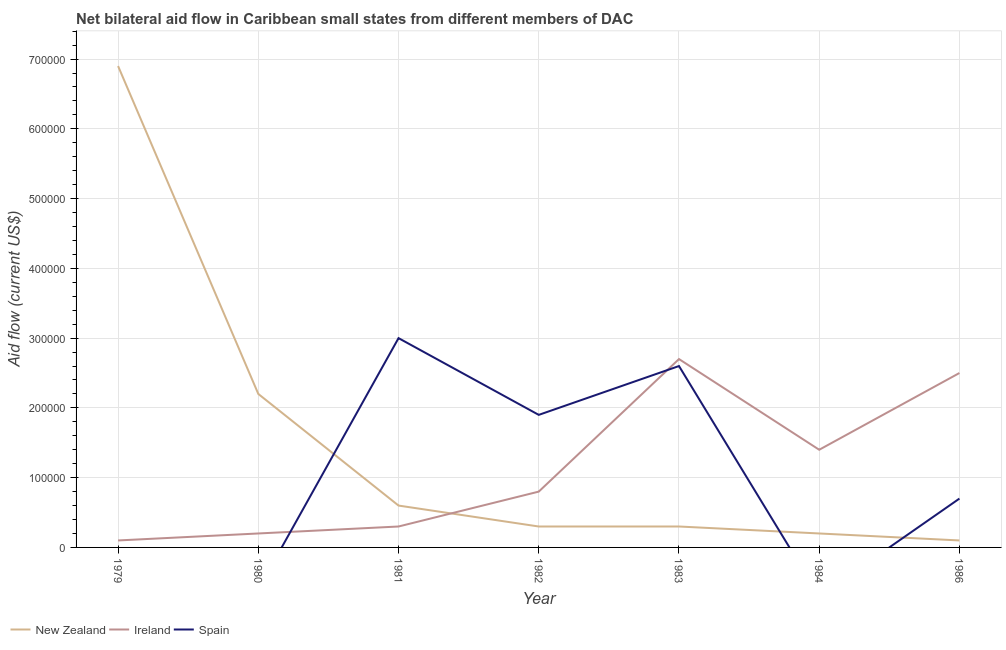Is the number of lines equal to the number of legend labels?
Offer a very short reply. No. What is the amount of aid provided by spain in 1983?
Offer a very short reply. 2.60e+05. Across all years, what is the maximum amount of aid provided by new zealand?
Provide a succinct answer. 6.90e+05. Across all years, what is the minimum amount of aid provided by ireland?
Make the answer very short. 10000. What is the total amount of aid provided by spain in the graph?
Provide a short and direct response. 8.20e+05. What is the difference between the amount of aid provided by new zealand in 1984 and that in 1986?
Provide a succinct answer. 10000. What is the difference between the amount of aid provided by new zealand in 1983 and the amount of aid provided by spain in 1981?
Ensure brevity in your answer.  -2.70e+05. What is the average amount of aid provided by spain per year?
Keep it short and to the point. 1.17e+05. In the year 1986, what is the difference between the amount of aid provided by new zealand and amount of aid provided by spain?
Keep it short and to the point. -6.00e+04. What is the ratio of the amount of aid provided by new zealand in 1979 to that in 1981?
Make the answer very short. 11.5. What is the difference between the highest and the lowest amount of aid provided by new zealand?
Your answer should be compact. 6.80e+05. In how many years, is the amount of aid provided by ireland greater than the average amount of aid provided by ireland taken over all years?
Make the answer very short. 3. Is the amount of aid provided by ireland strictly less than the amount of aid provided by new zealand over the years?
Provide a succinct answer. No. How many lines are there?
Your answer should be compact. 3. Are the values on the major ticks of Y-axis written in scientific E-notation?
Ensure brevity in your answer.  No. Does the graph contain any zero values?
Provide a short and direct response. Yes. Where does the legend appear in the graph?
Provide a succinct answer. Bottom left. How many legend labels are there?
Make the answer very short. 3. How are the legend labels stacked?
Your answer should be compact. Horizontal. What is the title of the graph?
Offer a terse response. Net bilateral aid flow in Caribbean small states from different members of DAC. What is the Aid flow (current US$) in New Zealand in 1979?
Make the answer very short. 6.90e+05. What is the Aid flow (current US$) of New Zealand in 1980?
Ensure brevity in your answer.  2.20e+05. What is the Aid flow (current US$) in Ireland in 1980?
Offer a very short reply. 2.00e+04. What is the Aid flow (current US$) in Spain in 1981?
Your response must be concise. 3.00e+05. What is the Aid flow (current US$) in Ireland in 1982?
Your response must be concise. 8.00e+04. What is the Aid flow (current US$) in Spain in 1982?
Keep it short and to the point. 1.90e+05. What is the Aid flow (current US$) of New Zealand in 1983?
Your answer should be very brief. 3.00e+04. What is the Aid flow (current US$) in Spain in 1983?
Provide a short and direct response. 2.60e+05. What is the Aid flow (current US$) in Ireland in 1984?
Ensure brevity in your answer.  1.40e+05. What is the Aid flow (current US$) of New Zealand in 1986?
Keep it short and to the point. 10000. What is the Aid flow (current US$) of Spain in 1986?
Make the answer very short. 7.00e+04. Across all years, what is the maximum Aid flow (current US$) in New Zealand?
Your answer should be very brief. 6.90e+05. Across all years, what is the minimum Aid flow (current US$) of New Zealand?
Provide a succinct answer. 10000. Across all years, what is the minimum Aid flow (current US$) in Ireland?
Give a very brief answer. 10000. What is the total Aid flow (current US$) in New Zealand in the graph?
Your answer should be very brief. 1.06e+06. What is the total Aid flow (current US$) of Ireland in the graph?
Provide a short and direct response. 8.00e+05. What is the total Aid flow (current US$) of Spain in the graph?
Your answer should be compact. 8.20e+05. What is the difference between the Aid flow (current US$) of New Zealand in 1979 and that in 1980?
Offer a very short reply. 4.70e+05. What is the difference between the Aid flow (current US$) in Ireland in 1979 and that in 1980?
Provide a succinct answer. -10000. What is the difference between the Aid flow (current US$) in New Zealand in 1979 and that in 1981?
Keep it short and to the point. 6.30e+05. What is the difference between the Aid flow (current US$) in Ireland in 1979 and that in 1981?
Offer a terse response. -2.00e+04. What is the difference between the Aid flow (current US$) of New Zealand in 1979 and that in 1984?
Keep it short and to the point. 6.70e+05. What is the difference between the Aid flow (current US$) in Ireland in 1979 and that in 1984?
Your answer should be very brief. -1.30e+05. What is the difference between the Aid flow (current US$) of New Zealand in 1979 and that in 1986?
Your answer should be very brief. 6.80e+05. What is the difference between the Aid flow (current US$) of Ireland in 1979 and that in 1986?
Ensure brevity in your answer.  -2.40e+05. What is the difference between the Aid flow (current US$) of New Zealand in 1980 and that in 1981?
Keep it short and to the point. 1.60e+05. What is the difference between the Aid flow (current US$) of New Zealand in 1980 and that in 1983?
Make the answer very short. 1.90e+05. What is the difference between the Aid flow (current US$) in Ireland in 1980 and that in 1983?
Provide a succinct answer. -2.50e+05. What is the difference between the Aid flow (current US$) in Ireland in 1980 and that in 1984?
Keep it short and to the point. -1.20e+05. What is the difference between the Aid flow (current US$) of Ireland in 1981 and that in 1982?
Keep it short and to the point. -5.00e+04. What is the difference between the Aid flow (current US$) of Spain in 1981 and that in 1982?
Your response must be concise. 1.10e+05. What is the difference between the Aid flow (current US$) of Ireland in 1981 and that in 1983?
Keep it short and to the point. -2.40e+05. What is the difference between the Aid flow (current US$) of New Zealand in 1981 and that in 1984?
Keep it short and to the point. 4.00e+04. What is the difference between the Aid flow (current US$) of Spain in 1981 and that in 1986?
Ensure brevity in your answer.  2.30e+05. What is the difference between the Aid flow (current US$) in New Zealand in 1982 and that in 1983?
Your answer should be compact. 0. What is the difference between the Aid flow (current US$) in Ireland in 1982 and that in 1983?
Offer a very short reply. -1.90e+05. What is the difference between the Aid flow (current US$) in Ireland in 1982 and that in 1984?
Keep it short and to the point. -6.00e+04. What is the difference between the Aid flow (current US$) of New Zealand in 1982 and that in 1986?
Make the answer very short. 2.00e+04. What is the difference between the Aid flow (current US$) in Ireland in 1982 and that in 1986?
Give a very brief answer. -1.70e+05. What is the difference between the Aid flow (current US$) of New Zealand in 1983 and that in 1984?
Provide a short and direct response. 10000. What is the difference between the Aid flow (current US$) of New Zealand in 1984 and that in 1986?
Your answer should be compact. 10000. What is the difference between the Aid flow (current US$) of New Zealand in 1979 and the Aid flow (current US$) of Ireland in 1980?
Provide a short and direct response. 6.70e+05. What is the difference between the Aid flow (current US$) of New Zealand in 1979 and the Aid flow (current US$) of Spain in 1981?
Provide a succinct answer. 3.90e+05. What is the difference between the Aid flow (current US$) of New Zealand in 1979 and the Aid flow (current US$) of Spain in 1982?
Offer a terse response. 5.00e+05. What is the difference between the Aid flow (current US$) in Ireland in 1979 and the Aid flow (current US$) in Spain in 1982?
Give a very brief answer. -1.80e+05. What is the difference between the Aid flow (current US$) of Ireland in 1979 and the Aid flow (current US$) of Spain in 1983?
Give a very brief answer. -2.50e+05. What is the difference between the Aid flow (current US$) in New Zealand in 1979 and the Aid flow (current US$) in Ireland in 1986?
Make the answer very short. 4.40e+05. What is the difference between the Aid flow (current US$) in New Zealand in 1979 and the Aid flow (current US$) in Spain in 1986?
Provide a short and direct response. 6.20e+05. What is the difference between the Aid flow (current US$) in New Zealand in 1980 and the Aid flow (current US$) in Ireland in 1981?
Your answer should be very brief. 1.90e+05. What is the difference between the Aid flow (current US$) of New Zealand in 1980 and the Aid flow (current US$) of Spain in 1981?
Your answer should be compact. -8.00e+04. What is the difference between the Aid flow (current US$) in Ireland in 1980 and the Aid flow (current US$) in Spain in 1981?
Provide a short and direct response. -2.80e+05. What is the difference between the Aid flow (current US$) in New Zealand in 1980 and the Aid flow (current US$) in Spain in 1983?
Provide a succinct answer. -4.00e+04. What is the difference between the Aid flow (current US$) of New Zealand in 1980 and the Aid flow (current US$) of Spain in 1986?
Provide a succinct answer. 1.50e+05. What is the difference between the Aid flow (current US$) of New Zealand in 1981 and the Aid flow (current US$) of Ireland in 1982?
Give a very brief answer. -2.00e+04. What is the difference between the Aid flow (current US$) in New Zealand in 1981 and the Aid flow (current US$) in Spain in 1982?
Make the answer very short. -1.30e+05. What is the difference between the Aid flow (current US$) of New Zealand in 1981 and the Aid flow (current US$) of Ireland in 1983?
Offer a terse response. -2.10e+05. What is the difference between the Aid flow (current US$) in New Zealand in 1981 and the Aid flow (current US$) in Ireland in 1986?
Your answer should be very brief. -1.90e+05. What is the difference between the Aid flow (current US$) in New Zealand in 1982 and the Aid flow (current US$) in Spain in 1983?
Your response must be concise. -2.30e+05. What is the difference between the Aid flow (current US$) in New Zealand in 1982 and the Aid flow (current US$) in Ireland in 1984?
Your answer should be compact. -1.10e+05. What is the difference between the Aid flow (current US$) of New Zealand in 1982 and the Aid flow (current US$) of Ireland in 1986?
Keep it short and to the point. -2.20e+05. What is the difference between the Aid flow (current US$) in New Zealand in 1983 and the Aid flow (current US$) in Ireland in 1986?
Your answer should be very brief. -2.20e+05. What is the difference between the Aid flow (current US$) of New Zealand in 1983 and the Aid flow (current US$) of Spain in 1986?
Ensure brevity in your answer.  -4.00e+04. What is the difference between the Aid flow (current US$) of Ireland in 1983 and the Aid flow (current US$) of Spain in 1986?
Your response must be concise. 2.00e+05. What is the difference between the Aid flow (current US$) of New Zealand in 1984 and the Aid flow (current US$) of Ireland in 1986?
Provide a succinct answer. -2.30e+05. What is the difference between the Aid flow (current US$) of New Zealand in 1984 and the Aid flow (current US$) of Spain in 1986?
Your answer should be compact. -5.00e+04. What is the difference between the Aid flow (current US$) of Ireland in 1984 and the Aid flow (current US$) of Spain in 1986?
Provide a short and direct response. 7.00e+04. What is the average Aid flow (current US$) of New Zealand per year?
Your answer should be compact. 1.51e+05. What is the average Aid flow (current US$) in Ireland per year?
Your answer should be very brief. 1.14e+05. What is the average Aid flow (current US$) of Spain per year?
Provide a succinct answer. 1.17e+05. In the year 1979, what is the difference between the Aid flow (current US$) of New Zealand and Aid flow (current US$) of Ireland?
Provide a succinct answer. 6.80e+05. In the year 1981, what is the difference between the Aid flow (current US$) in Ireland and Aid flow (current US$) in Spain?
Give a very brief answer. -2.70e+05. In the year 1982, what is the difference between the Aid flow (current US$) in New Zealand and Aid flow (current US$) in Ireland?
Make the answer very short. -5.00e+04. In the year 1982, what is the difference between the Aid flow (current US$) in New Zealand and Aid flow (current US$) in Spain?
Your answer should be very brief. -1.60e+05. In the year 1982, what is the difference between the Aid flow (current US$) of Ireland and Aid flow (current US$) of Spain?
Give a very brief answer. -1.10e+05. In the year 1983, what is the difference between the Aid flow (current US$) in New Zealand and Aid flow (current US$) in Ireland?
Your answer should be compact. -2.40e+05. In the year 1986, what is the difference between the Aid flow (current US$) in New Zealand and Aid flow (current US$) in Spain?
Your response must be concise. -6.00e+04. What is the ratio of the Aid flow (current US$) of New Zealand in 1979 to that in 1980?
Offer a terse response. 3.14. What is the ratio of the Aid flow (current US$) in Ireland in 1979 to that in 1980?
Ensure brevity in your answer.  0.5. What is the ratio of the Aid flow (current US$) in New Zealand in 1979 to that in 1981?
Your answer should be very brief. 11.5. What is the ratio of the Aid flow (current US$) of New Zealand in 1979 to that in 1983?
Provide a succinct answer. 23. What is the ratio of the Aid flow (current US$) in Ireland in 1979 to that in 1983?
Offer a very short reply. 0.04. What is the ratio of the Aid flow (current US$) of New Zealand in 1979 to that in 1984?
Provide a succinct answer. 34.5. What is the ratio of the Aid flow (current US$) in Ireland in 1979 to that in 1984?
Your response must be concise. 0.07. What is the ratio of the Aid flow (current US$) of New Zealand in 1979 to that in 1986?
Offer a very short reply. 69. What is the ratio of the Aid flow (current US$) of Ireland in 1979 to that in 1986?
Give a very brief answer. 0.04. What is the ratio of the Aid flow (current US$) of New Zealand in 1980 to that in 1981?
Ensure brevity in your answer.  3.67. What is the ratio of the Aid flow (current US$) in New Zealand in 1980 to that in 1982?
Make the answer very short. 7.33. What is the ratio of the Aid flow (current US$) in Ireland in 1980 to that in 1982?
Keep it short and to the point. 0.25. What is the ratio of the Aid flow (current US$) of New Zealand in 1980 to that in 1983?
Your answer should be very brief. 7.33. What is the ratio of the Aid flow (current US$) of Ireland in 1980 to that in 1983?
Keep it short and to the point. 0.07. What is the ratio of the Aid flow (current US$) in New Zealand in 1980 to that in 1984?
Your response must be concise. 11. What is the ratio of the Aid flow (current US$) in Ireland in 1980 to that in 1984?
Offer a terse response. 0.14. What is the ratio of the Aid flow (current US$) of Ireland in 1980 to that in 1986?
Make the answer very short. 0.08. What is the ratio of the Aid flow (current US$) of Ireland in 1981 to that in 1982?
Offer a terse response. 0.38. What is the ratio of the Aid flow (current US$) of Spain in 1981 to that in 1982?
Your response must be concise. 1.58. What is the ratio of the Aid flow (current US$) in Ireland in 1981 to that in 1983?
Provide a short and direct response. 0.11. What is the ratio of the Aid flow (current US$) of Spain in 1981 to that in 1983?
Give a very brief answer. 1.15. What is the ratio of the Aid flow (current US$) in New Zealand in 1981 to that in 1984?
Your answer should be very brief. 3. What is the ratio of the Aid flow (current US$) in Ireland in 1981 to that in 1984?
Offer a terse response. 0.21. What is the ratio of the Aid flow (current US$) in New Zealand in 1981 to that in 1986?
Your answer should be compact. 6. What is the ratio of the Aid flow (current US$) of Ireland in 1981 to that in 1986?
Provide a short and direct response. 0.12. What is the ratio of the Aid flow (current US$) in Spain in 1981 to that in 1986?
Your response must be concise. 4.29. What is the ratio of the Aid flow (current US$) of Ireland in 1982 to that in 1983?
Provide a short and direct response. 0.3. What is the ratio of the Aid flow (current US$) of Spain in 1982 to that in 1983?
Ensure brevity in your answer.  0.73. What is the ratio of the Aid flow (current US$) in New Zealand in 1982 to that in 1984?
Your answer should be very brief. 1.5. What is the ratio of the Aid flow (current US$) in Ireland in 1982 to that in 1986?
Offer a very short reply. 0.32. What is the ratio of the Aid flow (current US$) in Spain in 1982 to that in 1986?
Your answer should be compact. 2.71. What is the ratio of the Aid flow (current US$) in Ireland in 1983 to that in 1984?
Your response must be concise. 1.93. What is the ratio of the Aid flow (current US$) in Spain in 1983 to that in 1986?
Your answer should be compact. 3.71. What is the ratio of the Aid flow (current US$) of New Zealand in 1984 to that in 1986?
Offer a terse response. 2. What is the ratio of the Aid flow (current US$) of Ireland in 1984 to that in 1986?
Your answer should be very brief. 0.56. What is the difference between the highest and the second highest Aid flow (current US$) in New Zealand?
Keep it short and to the point. 4.70e+05. What is the difference between the highest and the second highest Aid flow (current US$) in Spain?
Ensure brevity in your answer.  4.00e+04. What is the difference between the highest and the lowest Aid flow (current US$) of New Zealand?
Offer a terse response. 6.80e+05. What is the difference between the highest and the lowest Aid flow (current US$) of Ireland?
Provide a succinct answer. 2.60e+05. What is the difference between the highest and the lowest Aid flow (current US$) of Spain?
Provide a succinct answer. 3.00e+05. 